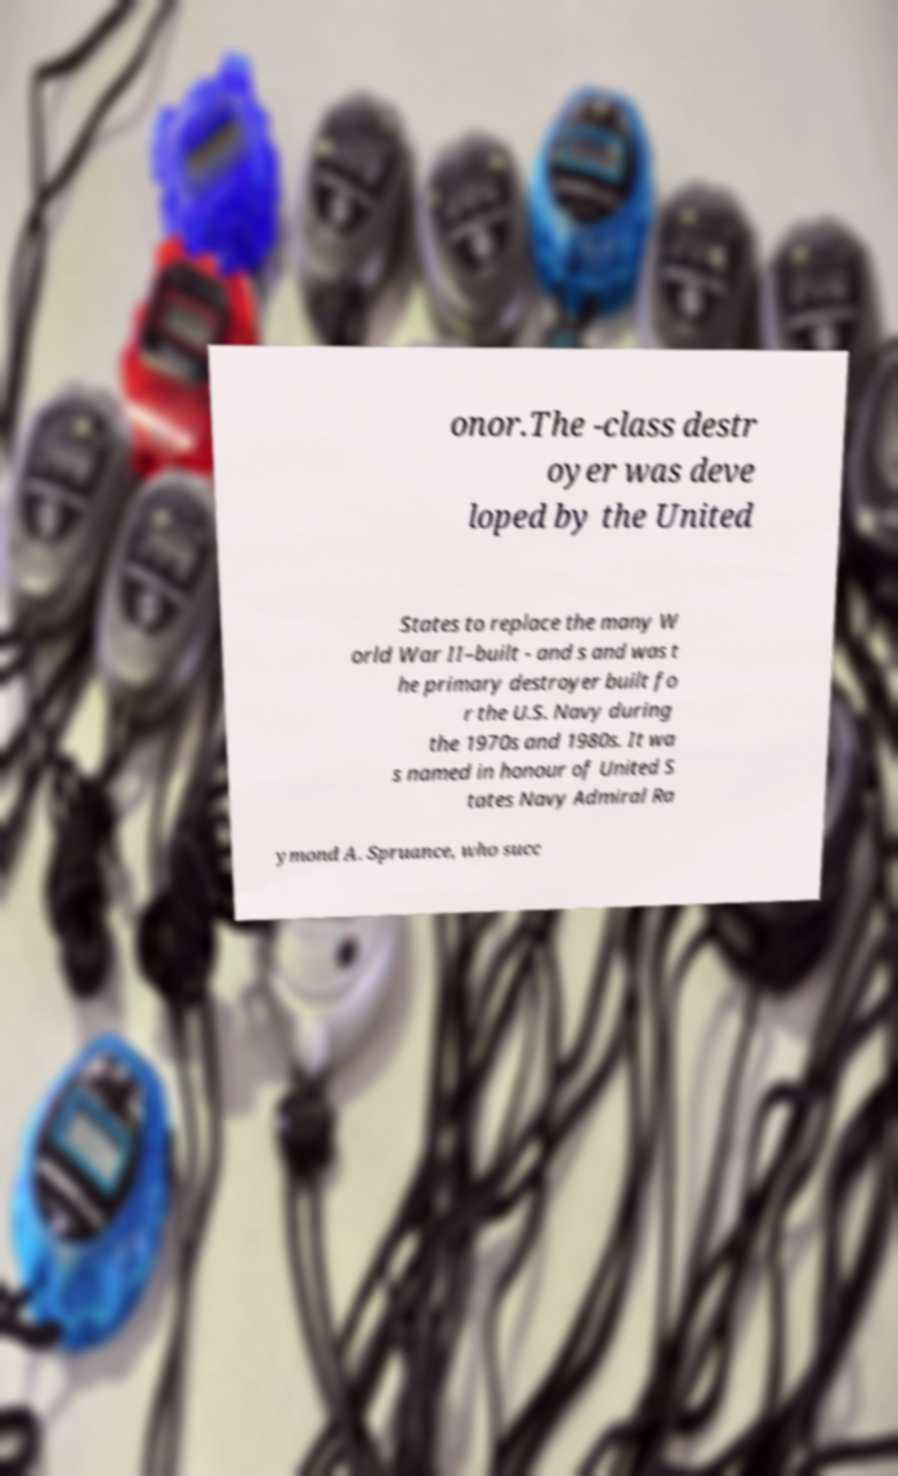What messages or text are displayed in this image? I need them in a readable, typed format. onor.The -class destr oyer was deve loped by the United States to replace the many W orld War II–built - and s and was t he primary destroyer built fo r the U.S. Navy during the 1970s and 1980s. It wa s named in honour of United S tates Navy Admiral Ra ymond A. Spruance, who succ 